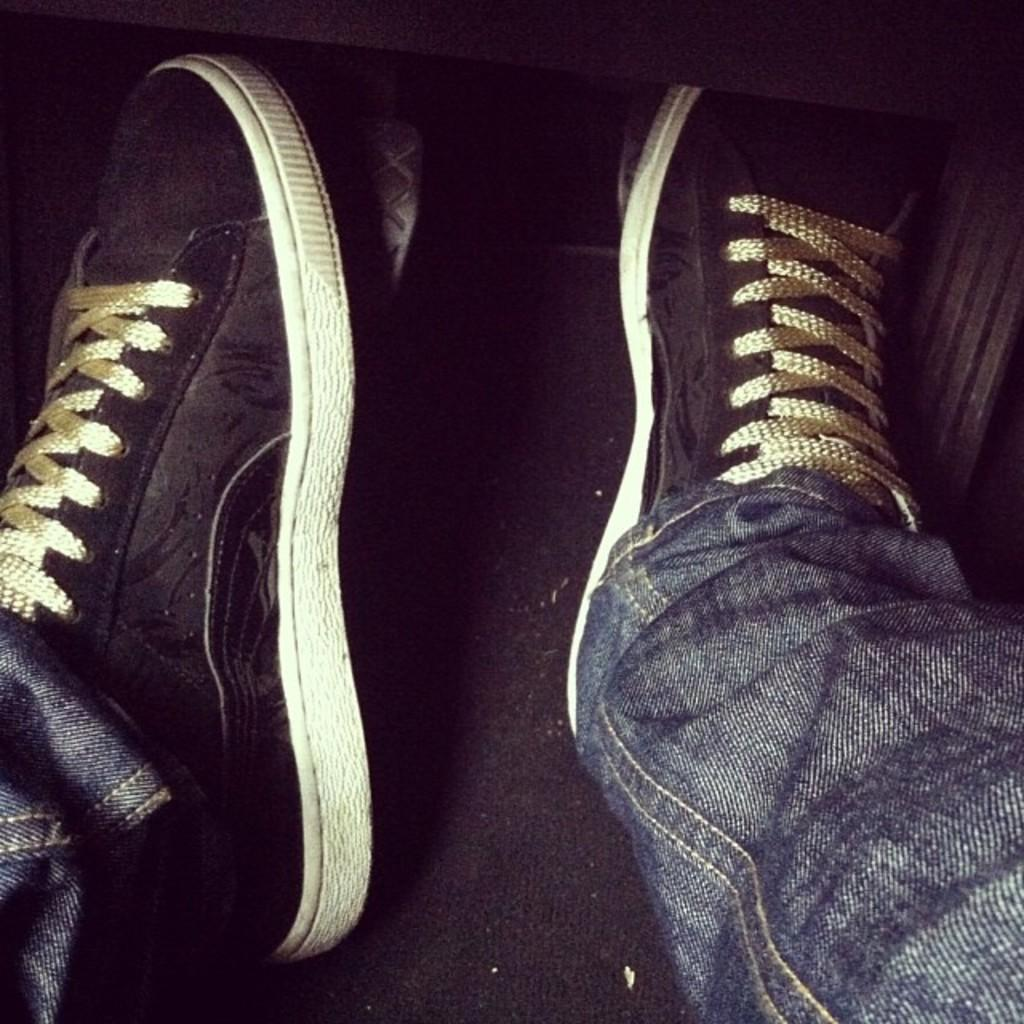What body part can be seen in the image? There are legs visible in the image. What type of footwear is the person wearing? The person is wearing shoes. Can you see the crow on the person's wrist in the image? There is no crow present in the image, and the person's wrist is not visible. 